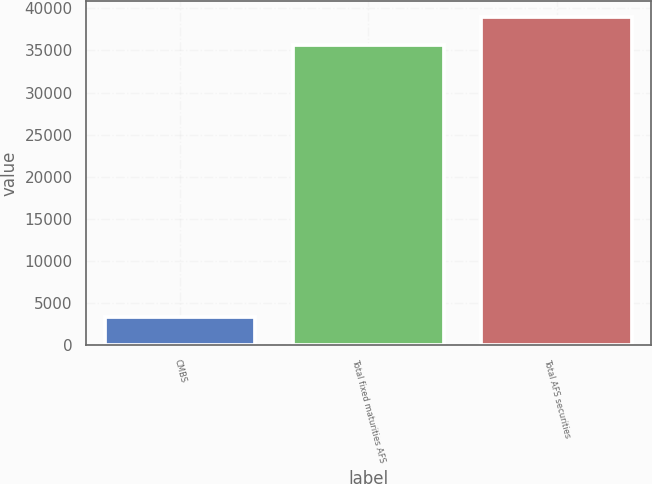Convert chart. <chart><loc_0><loc_0><loc_500><loc_500><bar_chart><fcel>CMBS<fcel>Total fixed maturities AFS<fcel>Total AFS securities<nl><fcel>3304<fcel>35612<fcel>38933.5<nl></chart> 